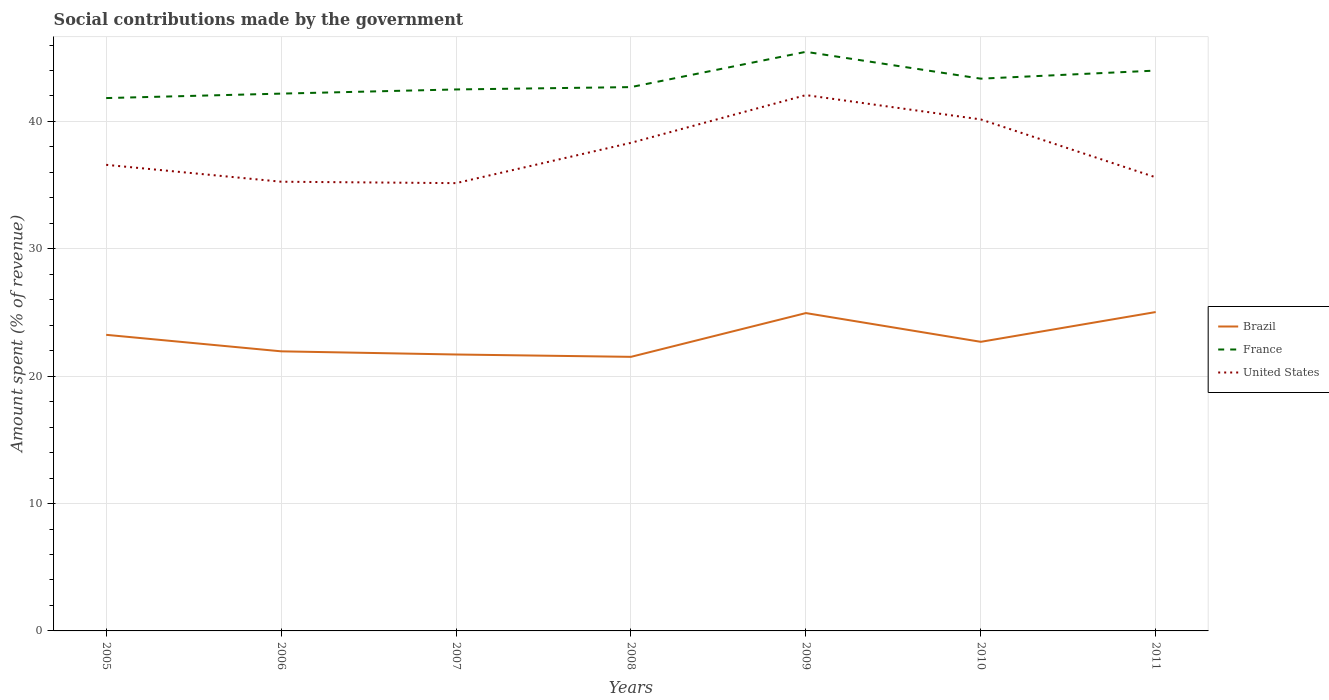How many different coloured lines are there?
Offer a very short reply. 3. Does the line corresponding to France intersect with the line corresponding to Brazil?
Make the answer very short. No. Is the number of lines equal to the number of legend labels?
Your answer should be compact. Yes. Across all years, what is the maximum amount spent (in %) on social contributions in United States?
Offer a very short reply. 35.16. In which year was the amount spent (in %) on social contributions in France maximum?
Provide a succinct answer. 2005. What is the total amount spent (in %) on social contributions in United States in the graph?
Give a very brief answer. 0.98. What is the difference between the highest and the second highest amount spent (in %) on social contributions in United States?
Keep it short and to the point. 6.91. Is the amount spent (in %) on social contributions in Brazil strictly greater than the amount spent (in %) on social contributions in France over the years?
Offer a terse response. Yes. How many years are there in the graph?
Your response must be concise. 7. What is the difference between two consecutive major ticks on the Y-axis?
Your answer should be very brief. 10. Are the values on the major ticks of Y-axis written in scientific E-notation?
Give a very brief answer. No. Does the graph contain grids?
Your answer should be very brief. Yes. Where does the legend appear in the graph?
Offer a very short reply. Center right. How many legend labels are there?
Offer a terse response. 3. How are the legend labels stacked?
Provide a succinct answer. Vertical. What is the title of the graph?
Make the answer very short. Social contributions made by the government. Does "Spain" appear as one of the legend labels in the graph?
Offer a terse response. No. What is the label or title of the Y-axis?
Your answer should be very brief. Amount spent (% of revenue). What is the Amount spent (% of revenue) in Brazil in 2005?
Your answer should be very brief. 23.25. What is the Amount spent (% of revenue) of France in 2005?
Offer a very short reply. 41.83. What is the Amount spent (% of revenue) of United States in 2005?
Keep it short and to the point. 36.59. What is the Amount spent (% of revenue) of Brazil in 2006?
Offer a very short reply. 21.95. What is the Amount spent (% of revenue) of France in 2006?
Your answer should be compact. 42.18. What is the Amount spent (% of revenue) of United States in 2006?
Give a very brief answer. 35.27. What is the Amount spent (% of revenue) of Brazil in 2007?
Ensure brevity in your answer.  21.7. What is the Amount spent (% of revenue) in France in 2007?
Your answer should be compact. 42.51. What is the Amount spent (% of revenue) in United States in 2007?
Your response must be concise. 35.16. What is the Amount spent (% of revenue) of Brazil in 2008?
Give a very brief answer. 21.52. What is the Amount spent (% of revenue) in France in 2008?
Offer a terse response. 42.7. What is the Amount spent (% of revenue) of United States in 2008?
Your answer should be compact. 38.32. What is the Amount spent (% of revenue) in Brazil in 2009?
Make the answer very short. 24.95. What is the Amount spent (% of revenue) in France in 2009?
Offer a terse response. 45.46. What is the Amount spent (% of revenue) of United States in 2009?
Your answer should be very brief. 42.07. What is the Amount spent (% of revenue) of Brazil in 2010?
Give a very brief answer. 22.7. What is the Amount spent (% of revenue) of France in 2010?
Your answer should be very brief. 43.36. What is the Amount spent (% of revenue) of United States in 2010?
Your response must be concise. 40.16. What is the Amount spent (% of revenue) in Brazil in 2011?
Your answer should be very brief. 25.03. What is the Amount spent (% of revenue) of France in 2011?
Your answer should be very brief. 43.99. What is the Amount spent (% of revenue) in United States in 2011?
Your answer should be compact. 35.61. Across all years, what is the maximum Amount spent (% of revenue) of Brazil?
Offer a very short reply. 25.03. Across all years, what is the maximum Amount spent (% of revenue) in France?
Provide a short and direct response. 45.46. Across all years, what is the maximum Amount spent (% of revenue) of United States?
Provide a succinct answer. 42.07. Across all years, what is the minimum Amount spent (% of revenue) in Brazil?
Ensure brevity in your answer.  21.52. Across all years, what is the minimum Amount spent (% of revenue) in France?
Provide a succinct answer. 41.83. Across all years, what is the minimum Amount spent (% of revenue) of United States?
Make the answer very short. 35.16. What is the total Amount spent (% of revenue) in Brazil in the graph?
Make the answer very short. 161.1. What is the total Amount spent (% of revenue) in France in the graph?
Make the answer very short. 302.04. What is the total Amount spent (% of revenue) of United States in the graph?
Your response must be concise. 263.17. What is the difference between the Amount spent (% of revenue) of Brazil in 2005 and that in 2006?
Your answer should be very brief. 1.3. What is the difference between the Amount spent (% of revenue) in France in 2005 and that in 2006?
Make the answer very short. -0.35. What is the difference between the Amount spent (% of revenue) of United States in 2005 and that in 2006?
Offer a terse response. 1.33. What is the difference between the Amount spent (% of revenue) in Brazil in 2005 and that in 2007?
Give a very brief answer. 1.55. What is the difference between the Amount spent (% of revenue) of France in 2005 and that in 2007?
Offer a very short reply. -0.68. What is the difference between the Amount spent (% of revenue) of United States in 2005 and that in 2007?
Your response must be concise. 1.44. What is the difference between the Amount spent (% of revenue) of Brazil in 2005 and that in 2008?
Your response must be concise. 1.73. What is the difference between the Amount spent (% of revenue) of France in 2005 and that in 2008?
Keep it short and to the point. -0.86. What is the difference between the Amount spent (% of revenue) of United States in 2005 and that in 2008?
Your response must be concise. -1.73. What is the difference between the Amount spent (% of revenue) of Brazil in 2005 and that in 2009?
Make the answer very short. -1.71. What is the difference between the Amount spent (% of revenue) of France in 2005 and that in 2009?
Your answer should be compact. -3.63. What is the difference between the Amount spent (% of revenue) of United States in 2005 and that in 2009?
Your answer should be compact. -5.47. What is the difference between the Amount spent (% of revenue) in Brazil in 2005 and that in 2010?
Your answer should be very brief. 0.55. What is the difference between the Amount spent (% of revenue) of France in 2005 and that in 2010?
Offer a terse response. -1.52. What is the difference between the Amount spent (% of revenue) in United States in 2005 and that in 2010?
Your response must be concise. -3.56. What is the difference between the Amount spent (% of revenue) in Brazil in 2005 and that in 2011?
Offer a terse response. -1.79. What is the difference between the Amount spent (% of revenue) of France in 2005 and that in 2011?
Give a very brief answer. -2.16. What is the difference between the Amount spent (% of revenue) in Brazil in 2006 and that in 2007?
Make the answer very short. 0.25. What is the difference between the Amount spent (% of revenue) of France in 2006 and that in 2007?
Give a very brief answer. -0.33. What is the difference between the Amount spent (% of revenue) of United States in 2006 and that in 2007?
Ensure brevity in your answer.  0.11. What is the difference between the Amount spent (% of revenue) in Brazil in 2006 and that in 2008?
Offer a very short reply. 0.43. What is the difference between the Amount spent (% of revenue) in France in 2006 and that in 2008?
Your answer should be very brief. -0.51. What is the difference between the Amount spent (% of revenue) in United States in 2006 and that in 2008?
Your response must be concise. -3.05. What is the difference between the Amount spent (% of revenue) in Brazil in 2006 and that in 2009?
Ensure brevity in your answer.  -3. What is the difference between the Amount spent (% of revenue) in France in 2006 and that in 2009?
Provide a short and direct response. -3.28. What is the difference between the Amount spent (% of revenue) in United States in 2006 and that in 2009?
Give a very brief answer. -6.8. What is the difference between the Amount spent (% of revenue) of Brazil in 2006 and that in 2010?
Your answer should be compact. -0.75. What is the difference between the Amount spent (% of revenue) in France in 2006 and that in 2010?
Provide a succinct answer. -1.17. What is the difference between the Amount spent (% of revenue) of United States in 2006 and that in 2010?
Your answer should be compact. -4.89. What is the difference between the Amount spent (% of revenue) of Brazil in 2006 and that in 2011?
Provide a succinct answer. -3.08. What is the difference between the Amount spent (% of revenue) in France in 2006 and that in 2011?
Your answer should be very brief. -1.81. What is the difference between the Amount spent (% of revenue) in United States in 2006 and that in 2011?
Offer a terse response. -0.35. What is the difference between the Amount spent (% of revenue) in Brazil in 2007 and that in 2008?
Provide a succinct answer. 0.18. What is the difference between the Amount spent (% of revenue) of France in 2007 and that in 2008?
Provide a short and direct response. -0.18. What is the difference between the Amount spent (% of revenue) in United States in 2007 and that in 2008?
Provide a short and direct response. -3.16. What is the difference between the Amount spent (% of revenue) in Brazil in 2007 and that in 2009?
Make the answer very short. -3.25. What is the difference between the Amount spent (% of revenue) in France in 2007 and that in 2009?
Offer a very short reply. -2.95. What is the difference between the Amount spent (% of revenue) of United States in 2007 and that in 2009?
Offer a terse response. -6.91. What is the difference between the Amount spent (% of revenue) of Brazil in 2007 and that in 2010?
Provide a short and direct response. -1. What is the difference between the Amount spent (% of revenue) in France in 2007 and that in 2010?
Ensure brevity in your answer.  -0.85. What is the difference between the Amount spent (% of revenue) in United States in 2007 and that in 2010?
Your answer should be very brief. -5. What is the difference between the Amount spent (% of revenue) in Brazil in 2007 and that in 2011?
Ensure brevity in your answer.  -3.33. What is the difference between the Amount spent (% of revenue) of France in 2007 and that in 2011?
Your answer should be very brief. -1.48. What is the difference between the Amount spent (% of revenue) of United States in 2007 and that in 2011?
Provide a succinct answer. -0.46. What is the difference between the Amount spent (% of revenue) of Brazil in 2008 and that in 2009?
Your answer should be very brief. -3.44. What is the difference between the Amount spent (% of revenue) of France in 2008 and that in 2009?
Provide a succinct answer. -2.77. What is the difference between the Amount spent (% of revenue) of United States in 2008 and that in 2009?
Offer a terse response. -3.75. What is the difference between the Amount spent (% of revenue) of Brazil in 2008 and that in 2010?
Give a very brief answer. -1.18. What is the difference between the Amount spent (% of revenue) of France in 2008 and that in 2010?
Your answer should be compact. -0.66. What is the difference between the Amount spent (% of revenue) of United States in 2008 and that in 2010?
Keep it short and to the point. -1.84. What is the difference between the Amount spent (% of revenue) of Brazil in 2008 and that in 2011?
Provide a short and direct response. -3.52. What is the difference between the Amount spent (% of revenue) in France in 2008 and that in 2011?
Offer a terse response. -1.3. What is the difference between the Amount spent (% of revenue) of United States in 2008 and that in 2011?
Keep it short and to the point. 2.71. What is the difference between the Amount spent (% of revenue) of Brazil in 2009 and that in 2010?
Your answer should be very brief. 2.26. What is the difference between the Amount spent (% of revenue) of France in 2009 and that in 2010?
Your response must be concise. 2.11. What is the difference between the Amount spent (% of revenue) in United States in 2009 and that in 2010?
Provide a short and direct response. 1.91. What is the difference between the Amount spent (% of revenue) of Brazil in 2009 and that in 2011?
Provide a succinct answer. -0.08. What is the difference between the Amount spent (% of revenue) in France in 2009 and that in 2011?
Give a very brief answer. 1.47. What is the difference between the Amount spent (% of revenue) in United States in 2009 and that in 2011?
Make the answer very short. 6.45. What is the difference between the Amount spent (% of revenue) of Brazil in 2010 and that in 2011?
Keep it short and to the point. -2.34. What is the difference between the Amount spent (% of revenue) in France in 2010 and that in 2011?
Your response must be concise. -0.63. What is the difference between the Amount spent (% of revenue) of United States in 2010 and that in 2011?
Keep it short and to the point. 4.55. What is the difference between the Amount spent (% of revenue) of Brazil in 2005 and the Amount spent (% of revenue) of France in 2006?
Keep it short and to the point. -18.94. What is the difference between the Amount spent (% of revenue) in Brazil in 2005 and the Amount spent (% of revenue) in United States in 2006?
Give a very brief answer. -12.02. What is the difference between the Amount spent (% of revenue) in France in 2005 and the Amount spent (% of revenue) in United States in 2006?
Your answer should be compact. 6.57. What is the difference between the Amount spent (% of revenue) in Brazil in 2005 and the Amount spent (% of revenue) in France in 2007?
Your response must be concise. -19.26. What is the difference between the Amount spent (% of revenue) in Brazil in 2005 and the Amount spent (% of revenue) in United States in 2007?
Your answer should be compact. -11.91. What is the difference between the Amount spent (% of revenue) of France in 2005 and the Amount spent (% of revenue) of United States in 2007?
Your answer should be very brief. 6.68. What is the difference between the Amount spent (% of revenue) of Brazil in 2005 and the Amount spent (% of revenue) of France in 2008?
Give a very brief answer. -19.45. What is the difference between the Amount spent (% of revenue) of Brazil in 2005 and the Amount spent (% of revenue) of United States in 2008?
Give a very brief answer. -15.07. What is the difference between the Amount spent (% of revenue) in France in 2005 and the Amount spent (% of revenue) in United States in 2008?
Keep it short and to the point. 3.51. What is the difference between the Amount spent (% of revenue) of Brazil in 2005 and the Amount spent (% of revenue) of France in 2009?
Your answer should be very brief. -22.22. What is the difference between the Amount spent (% of revenue) of Brazil in 2005 and the Amount spent (% of revenue) of United States in 2009?
Keep it short and to the point. -18.82. What is the difference between the Amount spent (% of revenue) in France in 2005 and the Amount spent (% of revenue) in United States in 2009?
Provide a succinct answer. -0.23. What is the difference between the Amount spent (% of revenue) in Brazil in 2005 and the Amount spent (% of revenue) in France in 2010?
Your answer should be very brief. -20.11. What is the difference between the Amount spent (% of revenue) in Brazil in 2005 and the Amount spent (% of revenue) in United States in 2010?
Provide a succinct answer. -16.91. What is the difference between the Amount spent (% of revenue) of France in 2005 and the Amount spent (% of revenue) of United States in 2010?
Offer a terse response. 1.68. What is the difference between the Amount spent (% of revenue) of Brazil in 2005 and the Amount spent (% of revenue) of France in 2011?
Give a very brief answer. -20.75. What is the difference between the Amount spent (% of revenue) in Brazil in 2005 and the Amount spent (% of revenue) in United States in 2011?
Provide a short and direct response. -12.37. What is the difference between the Amount spent (% of revenue) in France in 2005 and the Amount spent (% of revenue) in United States in 2011?
Your answer should be compact. 6.22. What is the difference between the Amount spent (% of revenue) of Brazil in 2006 and the Amount spent (% of revenue) of France in 2007?
Provide a succinct answer. -20.56. What is the difference between the Amount spent (% of revenue) in Brazil in 2006 and the Amount spent (% of revenue) in United States in 2007?
Keep it short and to the point. -13.2. What is the difference between the Amount spent (% of revenue) in France in 2006 and the Amount spent (% of revenue) in United States in 2007?
Make the answer very short. 7.03. What is the difference between the Amount spent (% of revenue) of Brazil in 2006 and the Amount spent (% of revenue) of France in 2008?
Provide a succinct answer. -20.74. What is the difference between the Amount spent (% of revenue) of Brazil in 2006 and the Amount spent (% of revenue) of United States in 2008?
Give a very brief answer. -16.37. What is the difference between the Amount spent (% of revenue) of France in 2006 and the Amount spent (% of revenue) of United States in 2008?
Ensure brevity in your answer.  3.86. What is the difference between the Amount spent (% of revenue) of Brazil in 2006 and the Amount spent (% of revenue) of France in 2009?
Your answer should be very brief. -23.51. What is the difference between the Amount spent (% of revenue) in Brazil in 2006 and the Amount spent (% of revenue) in United States in 2009?
Your answer should be very brief. -20.12. What is the difference between the Amount spent (% of revenue) in France in 2006 and the Amount spent (% of revenue) in United States in 2009?
Give a very brief answer. 0.12. What is the difference between the Amount spent (% of revenue) in Brazil in 2006 and the Amount spent (% of revenue) in France in 2010?
Provide a short and direct response. -21.41. What is the difference between the Amount spent (% of revenue) in Brazil in 2006 and the Amount spent (% of revenue) in United States in 2010?
Your answer should be very brief. -18.21. What is the difference between the Amount spent (% of revenue) of France in 2006 and the Amount spent (% of revenue) of United States in 2010?
Provide a succinct answer. 2.03. What is the difference between the Amount spent (% of revenue) of Brazil in 2006 and the Amount spent (% of revenue) of France in 2011?
Keep it short and to the point. -22.04. What is the difference between the Amount spent (% of revenue) in Brazil in 2006 and the Amount spent (% of revenue) in United States in 2011?
Offer a terse response. -13.66. What is the difference between the Amount spent (% of revenue) of France in 2006 and the Amount spent (% of revenue) of United States in 2011?
Your answer should be very brief. 6.57. What is the difference between the Amount spent (% of revenue) of Brazil in 2007 and the Amount spent (% of revenue) of France in 2008?
Your answer should be very brief. -20.99. What is the difference between the Amount spent (% of revenue) of Brazil in 2007 and the Amount spent (% of revenue) of United States in 2008?
Make the answer very short. -16.62. What is the difference between the Amount spent (% of revenue) in France in 2007 and the Amount spent (% of revenue) in United States in 2008?
Provide a short and direct response. 4.19. What is the difference between the Amount spent (% of revenue) in Brazil in 2007 and the Amount spent (% of revenue) in France in 2009?
Provide a succinct answer. -23.76. What is the difference between the Amount spent (% of revenue) of Brazil in 2007 and the Amount spent (% of revenue) of United States in 2009?
Make the answer very short. -20.37. What is the difference between the Amount spent (% of revenue) of France in 2007 and the Amount spent (% of revenue) of United States in 2009?
Provide a short and direct response. 0.44. What is the difference between the Amount spent (% of revenue) of Brazil in 2007 and the Amount spent (% of revenue) of France in 2010?
Provide a succinct answer. -21.66. What is the difference between the Amount spent (% of revenue) of Brazil in 2007 and the Amount spent (% of revenue) of United States in 2010?
Keep it short and to the point. -18.46. What is the difference between the Amount spent (% of revenue) in France in 2007 and the Amount spent (% of revenue) in United States in 2010?
Your answer should be very brief. 2.35. What is the difference between the Amount spent (% of revenue) in Brazil in 2007 and the Amount spent (% of revenue) in France in 2011?
Ensure brevity in your answer.  -22.29. What is the difference between the Amount spent (% of revenue) of Brazil in 2007 and the Amount spent (% of revenue) of United States in 2011?
Provide a short and direct response. -13.91. What is the difference between the Amount spent (% of revenue) in France in 2007 and the Amount spent (% of revenue) in United States in 2011?
Your answer should be compact. 6.9. What is the difference between the Amount spent (% of revenue) of Brazil in 2008 and the Amount spent (% of revenue) of France in 2009?
Make the answer very short. -23.95. What is the difference between the Amount spent (% of revenue) in Brazil in 2008 and the Amount spent (% of revenue) in United States in 2009?
Your answer should be very brief. -20.55. What is the difference between the Amount spent (% of revenue) of France in 2008 and the Amount spent (% of revenue) of United States in 2009?
Provide a succinct answer. 0.63. What is the difference between the Amount spent (% of revenue) in Brazil in 2008 and the Amount spent (% of revenue) in France in 2010?
Make the answer very short. -21.84. What is the difference between the Amount spent (% of revenue) of Brazil in 2008 and the Amount spent (% of revenue) of United States in 2010?
Provide a short and direct response. -18.64. What is the difference between the Amount spent (% of revenue) in France in 2008 and the Amount spent (% of revenue) in United States in 2010?
Offer a very short reply. 2.54. What is the difference between the Amount spent (% of revenue) of Brazil in 2008 and the Amount spent (% of revenue) of France in 2011?
Ensure brevity in your answer.  -22.47. What is the difference between the Amount spent (% of revenue) of Brazil in 2008 and the Amount spent (% of revenue) of United States in 2011?
Provide a succinct answer. -14.09. What is the difference between the Amount spent (% of revenue) in France in 2008 and the Amount spent (% of revenue) in United States in 2011?
Ensure brevity in your answer.  7.08. What is the difference between the Amount spent (% of revenue) in Brazil in 2009 and the Amount spent (% of revenue) in France in 2010?
Provide a succinct answer. -18.4. What is the difference between the Amount spent (% of revenue) of Brazil in 2009 and the Amount spent (% of revenue) of United States in 2010?
Provide a succinct answer. -15.2. What is the difference between the Amount spent (% of revenue) of France in 2009 and the Amount spent (% of revenue) of United States in 2010?
Provide a succinct answer. 5.31. What is the difference between the Amount spent (% of revenue) of Brazil in 2009 and the Amount spent (% of revenue) of France in 2011?
Provide a short and direct response. -19.04. What is the difference between the Amount spent (% of revenue) in Brazil in 2009 and the Amount spent (% of revenue) in United States in 2011?
Offer a very short reply. -10.66. What is the difference between the Amount spent (% of revenue) of France in 2009 and the Amount spent (% of revenue) of United States in 2011?
Make the answer very short. 9.85. What is the difference between the Amount spent (% of revenue) of Brazil in 2010 and the Amount spent (% of revenue) of France in 2011?
Offer a terse response. -21.29. What is the difference between the Amount spent (% of revenue) of Brazil in 2010 and the Amount spent (% of revenue) of United States in 2011?
Give a very brief answer. -12.91. What is the difference between the Amount spent (% of revenue) of France in 2010 and the Amount spent (% of revenue) of United States in 2011?
Provide a short and direct response. 7.75. What is the average Amount spent (% of revenue) of Brazil per year?
Offer a terse response. 23.01. What is the average Amount spent (% of revenue) in France per year?
Ensure brevity in your answer.  43.15. What is the average Amount spent (% of revenue) of United States per year?
Offer a terse response. 37.6. In the year 2005, what is the difference between the Amount spent (% of revenue) in Brazil and Amount spent (% of revenue) in France?
Offer a terse response. -18.59. In the year 2005, what is the difference between the Amount spent (% of revenue) of Brazil and Amount spent (% of revenue) of United States?
Offer a terse response. -13.35. In the year 2005, what is the difference between the Amount spent (% of revenue) in France and Amount spent (% of revenue) in United States?
Your answer should be very brief. 5.24. In the year 2006, what is the difference between the Amount spent (% of revenue) of Brazil and Amount spent (% of revenue) of France?
Your answer should be very brief. -20.23. In the year 2006, what is the difference between the Amount spent (% of revenue) in Brazil and Amount spent (% of revenue) in United States?
Make the answer very short. -13.32. In the year 2006, what is the difference between the Amount spent (% of revenue) of France and Amount spent (% of revenue) of United States?
Provide a short and direct response. 6.92. In the year 2007, what is the difference between the Amount spent (% of revenue) in Brazil and Amount spent (% of revenue) in France?
Offer a very short reply. -20.81. In the year 2007, what is the difference between the Amount spent (% of revenue) of Brazil and Amount spent (% of revenue) of United States?
Give a very brief answer. -13.45. In the year 2007, what is the difference between the Amount spent (% of revenue) in France and Amount spent (% of revenue) in United States?
Provide a short and direct response. 7.36. In the year 2008, what is the difference between the Amount spent (% of revenue) of Brazil and Amount spent (% of revenue) of France?
Make the answer very short. -21.18. In the year 2008, what is the difference between the Amount spent (% of revenue) in Brazil and Amount spent (% of revenue) in United States?
Your response must be concise. -16.8. In the year 2008, what is the difference between the Amount spent (% of revenue) of France and Amount spent (% of revenue) of United States?
Ensure brevity in your answer.  4.38. In the year 2009, what is the difference between the Amount spent (% of revenue) in Brazil and Amount spent (% of revenue) in France?
Your answer should be compact. -20.51. In the year 2009, what is the difference between the Amount spent (% of revenue) in Brazil and Amount spent (% of revenue) in United States?
Ensure brevity in your answer.  -17.11. In the year 2009, what is the difference between the Amount spent (% of revenue) in France and Amount spent (% of revenue) in United States?
Give a very brief answer. 3.4. In the year 2010, what is the difference between the Amount spent (% of revenue) of Brazil and Amount spent (% of revenue) of France?
Ensure brevity in your answer.  -20.66. In the year 2010, what is the difference between the Amount spent (% of revenue) in Brazil and Amount spent (% of revenue) in United States?
Ensure brevity in your answer.  -17.46. In the year 2010, what is the difference between the Amount spent (% of revenue) in France and Amount spent (% of revenue) in United States?
Provide a short and direct response. 3.2. In the year 2011, what is the difference between the Amount spent (% of revenue) in Brazil and Amount spent (% of revenue) in France?
Give a very brief answer. -18.96. In the year 2011, what is the difference between the Amount spent (% of revenue) of Brazil and Amount spent (% of revenue) of United States?
Your response must be concise. -10.58. In the year 2011, what is the difference between the Amount spent (% of revenue) in France and Amount spent (% of revenue) in United States?
Ensure brevity in your answer.  8.38. What is the ratio of the Amount spent (% of revenue) of Brazil in 2005 to that in 2006?
Provide a short and direct response. 1.06. What is the ratio of the Amount spent (% of revenue) in France in 2005 to that in 2006?
Your answer should be compact. 0.99. What is the ratio of the Amount spent (% of revenue) of United States in 2005 to that in 2006?
Ensure brevity in your answer.  1.04. What is the ratio of the Amount spent (% of revenue) in Brazil in 2005 to that in 2007?
Offer a terse response. 1.07. What is the ratio of the Amount spent (% of revenue) of France in 2005 to that in 2007?
Your answer should be compact. 0.98. What is the ratio of the Amount spent (% of revenue) in United States in 2005 to that in 2007?
Make the answer very short. 1.04. What is the ratio of the Amount spent (% of revenue) in Brazil in 2005 to that in 2008?
Provide a succinct answer. 1.08. What is the ratio of the Amount spent (% of revenue) of France in 2005 to that in 2008?
Your answer should be compact. 0.98. What is the ratio of the Amount spent (% of revenue) in United States in 2005 to that in 2008?
Your answer should be very brief. 0.95. What is the ratio of the Amount spent (% of revenue) in Brazil in 2005 to that in 2009?
Provide a succinct answer. 0.93. What is the ratio of the Amount spent (% of revenue) of France in 2005 to that in 2009?
Provide a succinct answer. 0.92. What is the ratio of the Amount spent (% of revenue) in United States in 2005 to that in 2009?
Give a very brief answer. 0.87. What is the ratio of the Amount spent (% of revenue) of Brazil in 2005 to that in 2010?
Provide a short and direct response. 1.02. What is the ratio of the Amount spent (% of revenue) in France in 2005 to that in 2010?
Your response must be concise. 0.96. What is the ratio of the Amount spent (% of revenue) of United States in 2005 to that in 2010?
Give a very brief answer. 0.91. What is the ratio of the Amount spent (% of revenue) in Brazil in 2005 to that in 2011?
Keep it short and to the point. 0.93. What is the ratio of the Amount spent (% of revenue) in France in 2005 to that in 2011?
Keep it short and to the point. 0.95. What is the ratio of the Amount spent (% of revenue) in United States in 2005 to that in 2011?
Make the answer very short. 1.03. What is the ratio of the Amount spent (% of revenue) of Brazil in 2006 to that in 2007?
Ensure brevity in your answer.  1.01. What is the ratio of the Amount spent (% of revenue) of France in 2006 to that in 2007?
Offer a terse response. 0.99. What is the ratio of the Amount spent (% of revenue) of United States in 2006 to that in 2007?
Your answer should be very brief. 1. What is the ratio of the Amount spent (% of revenue) of Brazil in 2006 to that in 2008?
Give a very brief answer. 1.02. What is the ratio of the Amount spent (% of revenue) in France in 2006 to that in 2008?
Offer a very short reply. 0.99. What is the ratio of the Amount spent (% of revenue) of United States in 2006 to that in 2008?
Ensure brevity in your answer.  0.92. What is the ratio of the Amount spent (% of revenue) in Brazil in 2006 to that in 2009?
Provide a short and direct response. 0.88. What is the ratio of the Amount spent (% of revenue) in France in 2006 to that in 2009?
Your answer should be compact. 0.93. What is the ratio of the Amount spent (% of revenue) of United States in 2006 to that in 2009?
Your answer should be compact. 0.84. What is the ratio of the Amount spent (% of revenue) of Brazil in 2006 to that in 2010?
Give a very brief answer. 0.97. What is the ratio of the Amount spent (% of revenue) of France in 2006 to that in 2010?
Your answer should be very brief. 0.97. What is the ratio of the Amount spent (% of revenue) in United States in 2006 to that in 2010?
Offer a terse response. 0.88. What is the ratio of the Amount spent (% of revenue) in Brazil in 2006 to that in 2011?
Offer a very short reply. 0.88. What is the ratio of the Amount spent (% of revenue) of France in 2006 to that in 2011?
Your answer should be very brief. 0.96. What is the ratio of the Amount spent (% of revenue) in United States in 2006 to that in 2011?
Your response must be concise. 0.99. What is the ratio of the Amount spent (% of revenue) in Brazil in 2007 to that in 2008?
Give a very brief answer. 1.01. What is the ratio of the Amount spent (% of revenue) of France in 2007 to that in 2008?
Offer a terse response. 1. What is the ratio of the Amount spent (% of revenue) in United States in 2007 to that in 2008?
Keep it short and to the point. 0.92. What is the ratio of the Amount spent (% of revenue) in Brazil in 2007 to that in 2009?
Ensure brevity in your answer.  0.87. What is the ratio of the Amount spent (% of revenue) of France in 2007 to that in 2009?
Offer a very short reply. 0.94. What is the ratio of the Amount spent (% of revenue) in United States in 2007 to that in 2009?
Your answer should be compact. 0.84. What is the ratio of the Amount spent (% of revenue) of Brazil in 2007 to that in 2010?
Keep it short and to the point. 0.96. What is the ratio of the Amount spent (% of revenue) in France in 2007 to that in 2010?
Your answer should be very brief. 0.98. What is the ratio of the Amount spent (% of revenue) of United States in 2007 to that in 2010?
Provide a short and direct response. 0.88. What is the ratio of the Amount spent (% of revenue) of Brazil in 2007 to that in 2011?
Your answer should be very brief. 0.87. What is the ratio of the Amount spent (% of revenue) in France in 2007 to that in 2011?
Keep it short and to the point. 0.97. What is the ratio of the Amount spent (% of revenue) of United States in 2007 to that in 2011?
Provide a succinct answer. 0.99. What is the ratio of the Amount spent (% of revenue) of Brazil in 2008 to that in 2009?
Ensure brevity in your answer.  0.86. What is the ratio of the Amount spent (% of revenue) of France in 2008 to that in 2009?
Ensure brevity in your answer.  0.94. What is the ratio of the Amount spent (% of revenue) of United States in 2008 to that in 2009?
Offer a terse response. 0.91. What is the ratio of the Amount spent (% of revenue) of Brazil in 2008 to that in 2010?
Offer a very short reply. 0.95. What is the ratio of the Amount spent (% of revenue) in France in 2008 to that in 2010?
Your response must be concise. 0.98. What is the ratio of the Amount spent (% of revenue) of United States in 2008 to that in 2010?
Make the answer very short. 0.95. What is the ratio of the Amount spent (% of revenue) in Brazil in 2008 to that in 2011?
Keep it short and to the point. 0.86. What is the ratio of the Amount spent (% of revenue) of France in 2008 to that in 2011?
Your answer should be very brief. 0.97. What is the ratio of the Amount spent (% of revenue) of United States in 2008 to that in 2011?
Make the answer very short. 1.08. What is the ratio of the Amount spent (% of revenue) of Brazil in 2009 to that in 2010?
Offer a very short reply. 1.1. What is the ratio of the Amount spent (% of revenue) in France in 2009 to that in 2010?
Provide a succinct answer. 1.05. What is the ratio of the Amount spent (% of revenue) of United States in 2009 to that in 2010?
Your answer should be very brief. 1.05. What is the ratio of the Amount spent (% of revenue) of Brazil in 2009 to that in 2011?
Your response must be concise. 1. What is the ratio of the Amount spent (% of revenue) in France in 2009 to that in 2011?
Ensure brevity in your answer.  1.03. What is the ratio of the Amount spent (% of revenue) in United States in 2009 to that in 2011?
Make the answer very short. 1.18. What is the ratio of the Amount spent (% of revenue) in Brazil in 2010 to that in 2011?
Provide a succinct answer. 0.91. What is the ratio of the Amount spent (% of revenue) in France in 2010 to that in 2011?
Offer a terse response. 0.99. What is the ratio of the Amount spent (% of revenue) in United States in 2010 to that in 2011?
Keep it short and to the point. 1.13. What is the difference between the highest and the second highest Amount spent (% of revenue) of Brazil?
Make the answer very short. 0.08. What is the difference between the highest and the second highest Amount spent (% of revenue) in France?
Provide a short and direct response. 1.47. What is the difference between the highest and the second highest Amount spent (% of revenue) of United States?
Provide a short and direct response. 1.91. What is the difference between the highest and the lowest Amount spent (% of revenue) of Brazil?
Provide a succinct answer. 3.52. What is the difference between the highest and the lowest Amount spent (% of revenue) of France?
Provide a succinct answer. 3.63. What is the difference between the highest and the lowest Amount spent (% of revenue) in United States?
Offer a terse response. 6.91. 